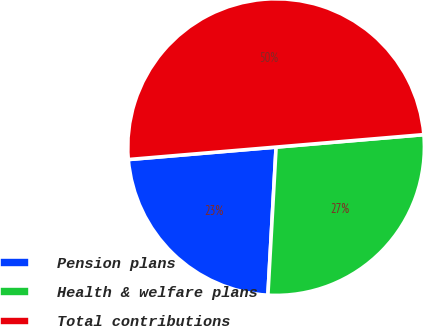<chart> <loc_0><loc_0><loc_500><loc_500><pie_chart><fcel>Pension plans<fcel>Health & welfare plans<fcel>Total contributions<nl><fcel>22.78%<fcel>27.22%<fcel>50.0%<nl></chart> 